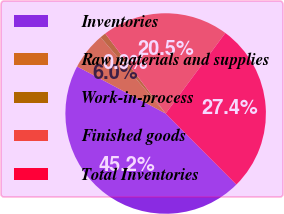<chart> <loc_0><loc_0><loc_500><loc_500><pie_chart><fcel>Inventories<fcel>Raw materials and supplies<fcel>Work-in-process<fcel>Finished goods<fcel>Total Inventories<nl><fcel>45.23%<fcel>5.99%<fcel>0.94%<fcel>20.45%<fcel>27.38%<nl></chart> 